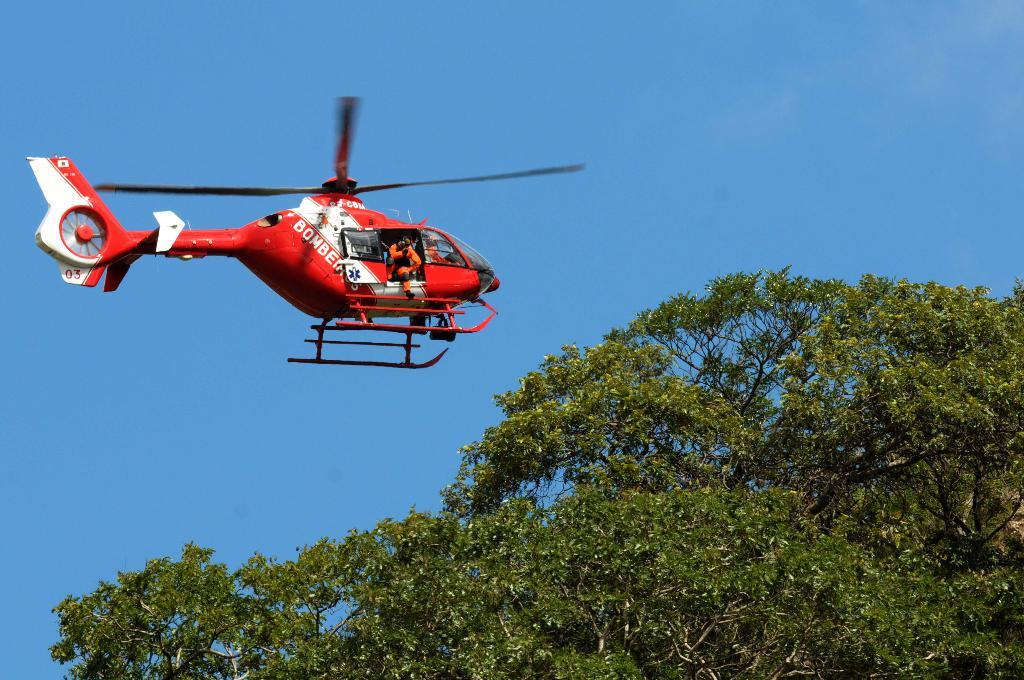What type of natural object can be seen in the image? There is a tree in the image. What is the color of the plane in the image? The plane in the image is red. What is visible at the top of the image? The sky is visible at the top of the image. Can you tell if there are any passengers inside the plane? Yes, there are people inside the plane. What type of shape is the lettuce in the image? There is no lettuce present in the image. What is the quill used for in the image? There is no quill present in the image. 